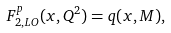Convert formula to latex. <formula><loc_0><loc_0><loc_500><loc_500>F _ { 2 , { L O } } ^ { p } ( x , Q ^ { 2 } ) = q ( x , M ) ,</formula> 